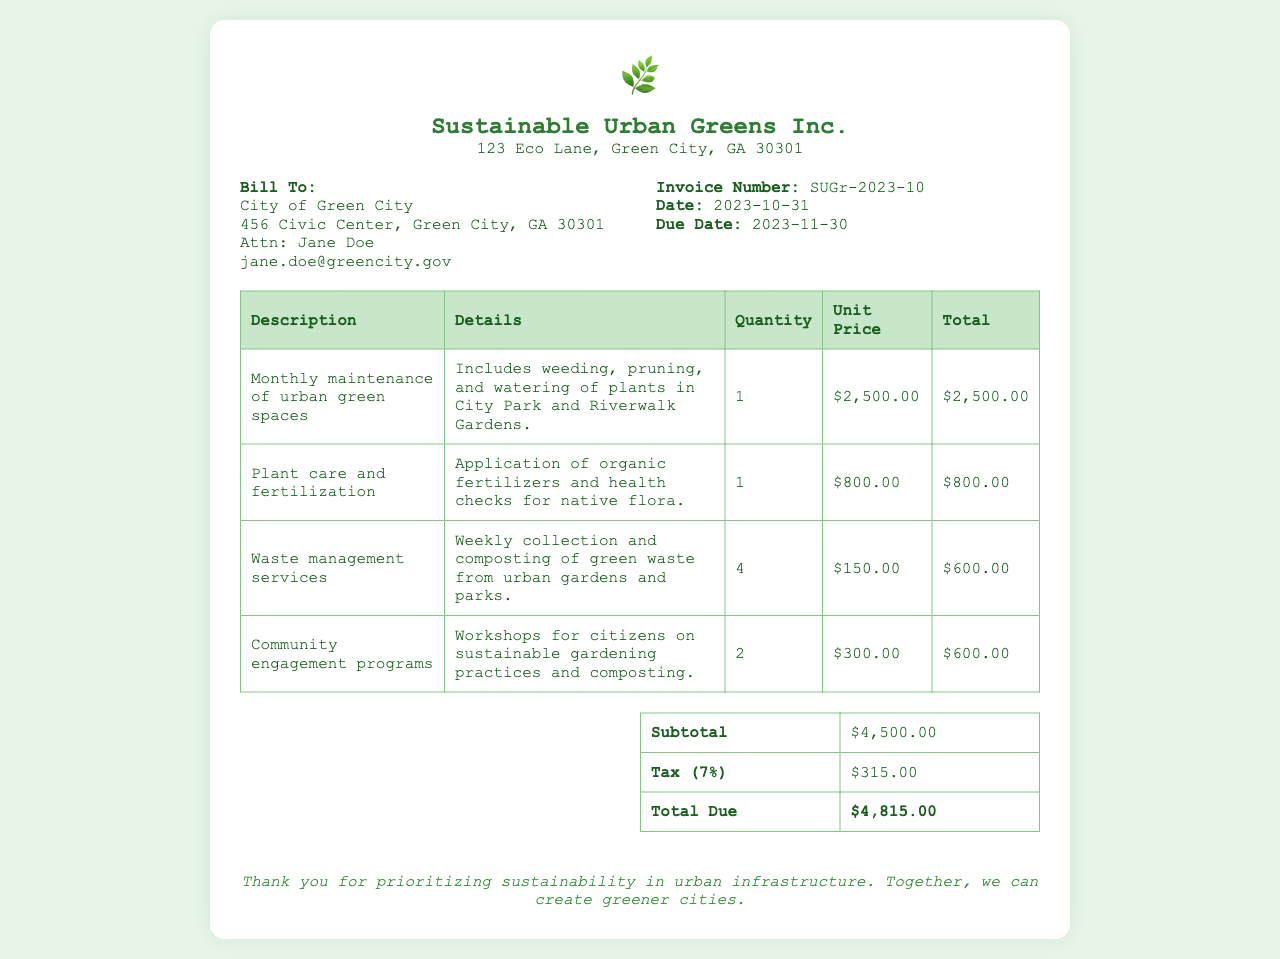What is the invoice number? The invoice number is listed in the document as a unique identifier for this transaction.
Answer: SUGr-2023-10 What is the total due amount? The total due is the final amount payable after tax, as stated in the summary section.
Answer: $4,815.00 Who is the client receiving the invoice? The client is identified as the recipient of the services provided by Sustainable Urban Greens Inc.
Answer: City of Green City What services are included in the monthly maintenance? This service includes tasks relating to the upkeep of green spaces.
Answer: Weeding, pruning, and watering of plants How much does plant care and fertilization cost? This cost is specified as the unit price for the service provided.
Answer: $800.00 What percentage is applied as tax? The tax value is given as a percentage of the subtotal, making it easier to calculate the total amount.
Answer: 7% How many community engagement programs were conducted? This detail indicates the number of workshops offered for community education.
Answer: 2 What is the subtotal before tax? The subtotal is calculated from the total of all services provided, before tax is applied.
Answer: $4,500.00 